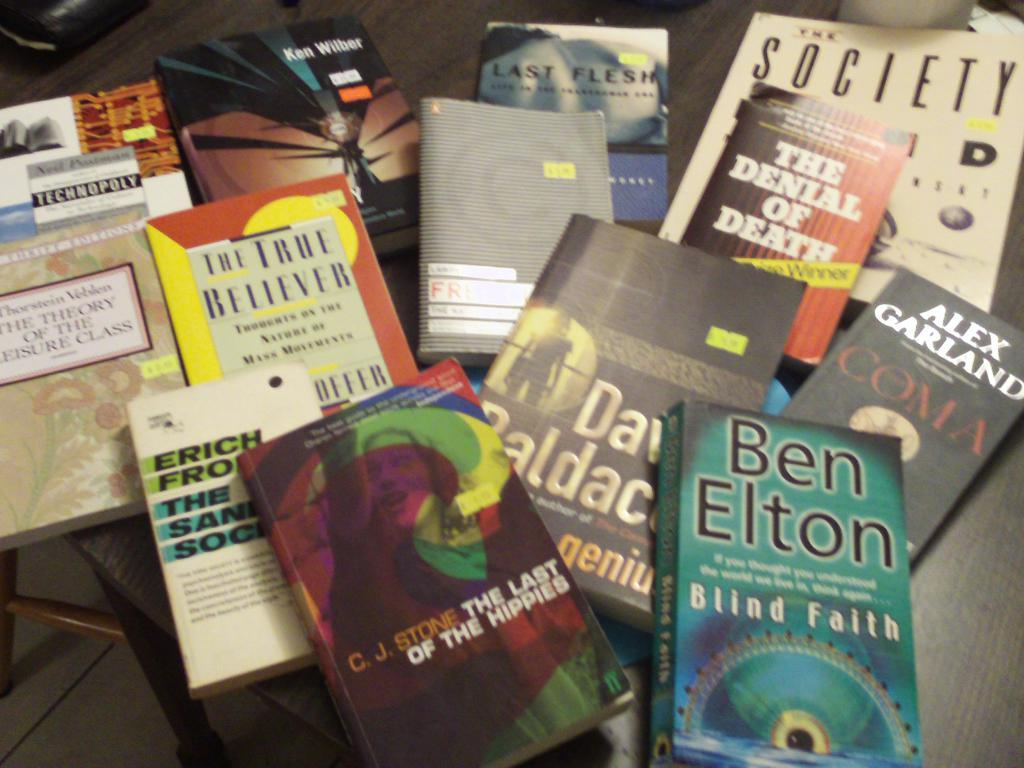<image>
Offer a succinct explanation of the picture presented. A copy of Blind Faith by Ben Elton sits with several other books on a table. 